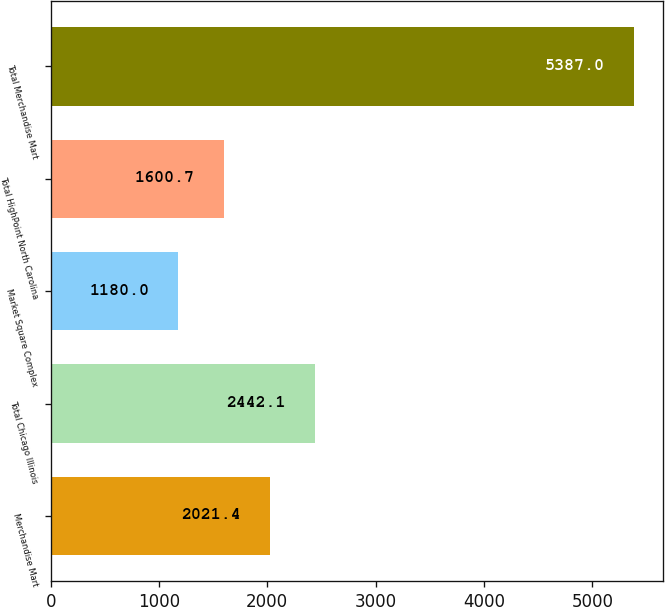Convert chart. <chart><loc_0><loc_0><loc_500><loc_500><bar_chart><fcel>Merchandise Mart<fcel>Total Chicago Illinois<fcel>Market Square Complex<fcel>Total HighPoint North Carolina<fcel>Total Merchandise Mart<nl><fcel>2021.4<fcel>2442.1<fcel>1180<fcel>1600.7<fcel>5387<nl></chart> 